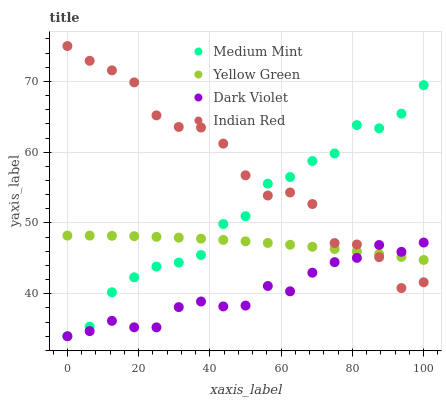Does Dark Violet have the minimum area under the curve?
Answer yes or no. Yes. Does Indian Red have the maximum area under the curve?
Answer yes or no. Yes. Does Yellow Green have the minimum area under the curve?
Answer yes or no. No. Does Yellow Green have the maximum area under the curve?
Answer yes or no. No. Is Yellow Green the smoothest?
Answer yes or no. Yes. Is Indian Red the roughest?
Answer yes or no. Yes. Is Indian Red the smoothest?
Answer yes or no. No. Is Yellow Green the roughest?
Answer yes or no. No. Does Medium Mint have the lowest value?
Answer yes or no. Yes. Does Indian Red have the lowest value?
Answer yes or no. No. Does Indian Red have the highest value?
Answer yes or no. Yes. Does Yellow Green have the highest value?
Answer yes or no. No. Does Medium Mint intersect Indian Red?
Answer yes or no. Yes. Is Medium Mint less than Indian Red?
Answer yes or no. No. Is Medium Mint greater than Indian Red?
Answer yes or no. No. 